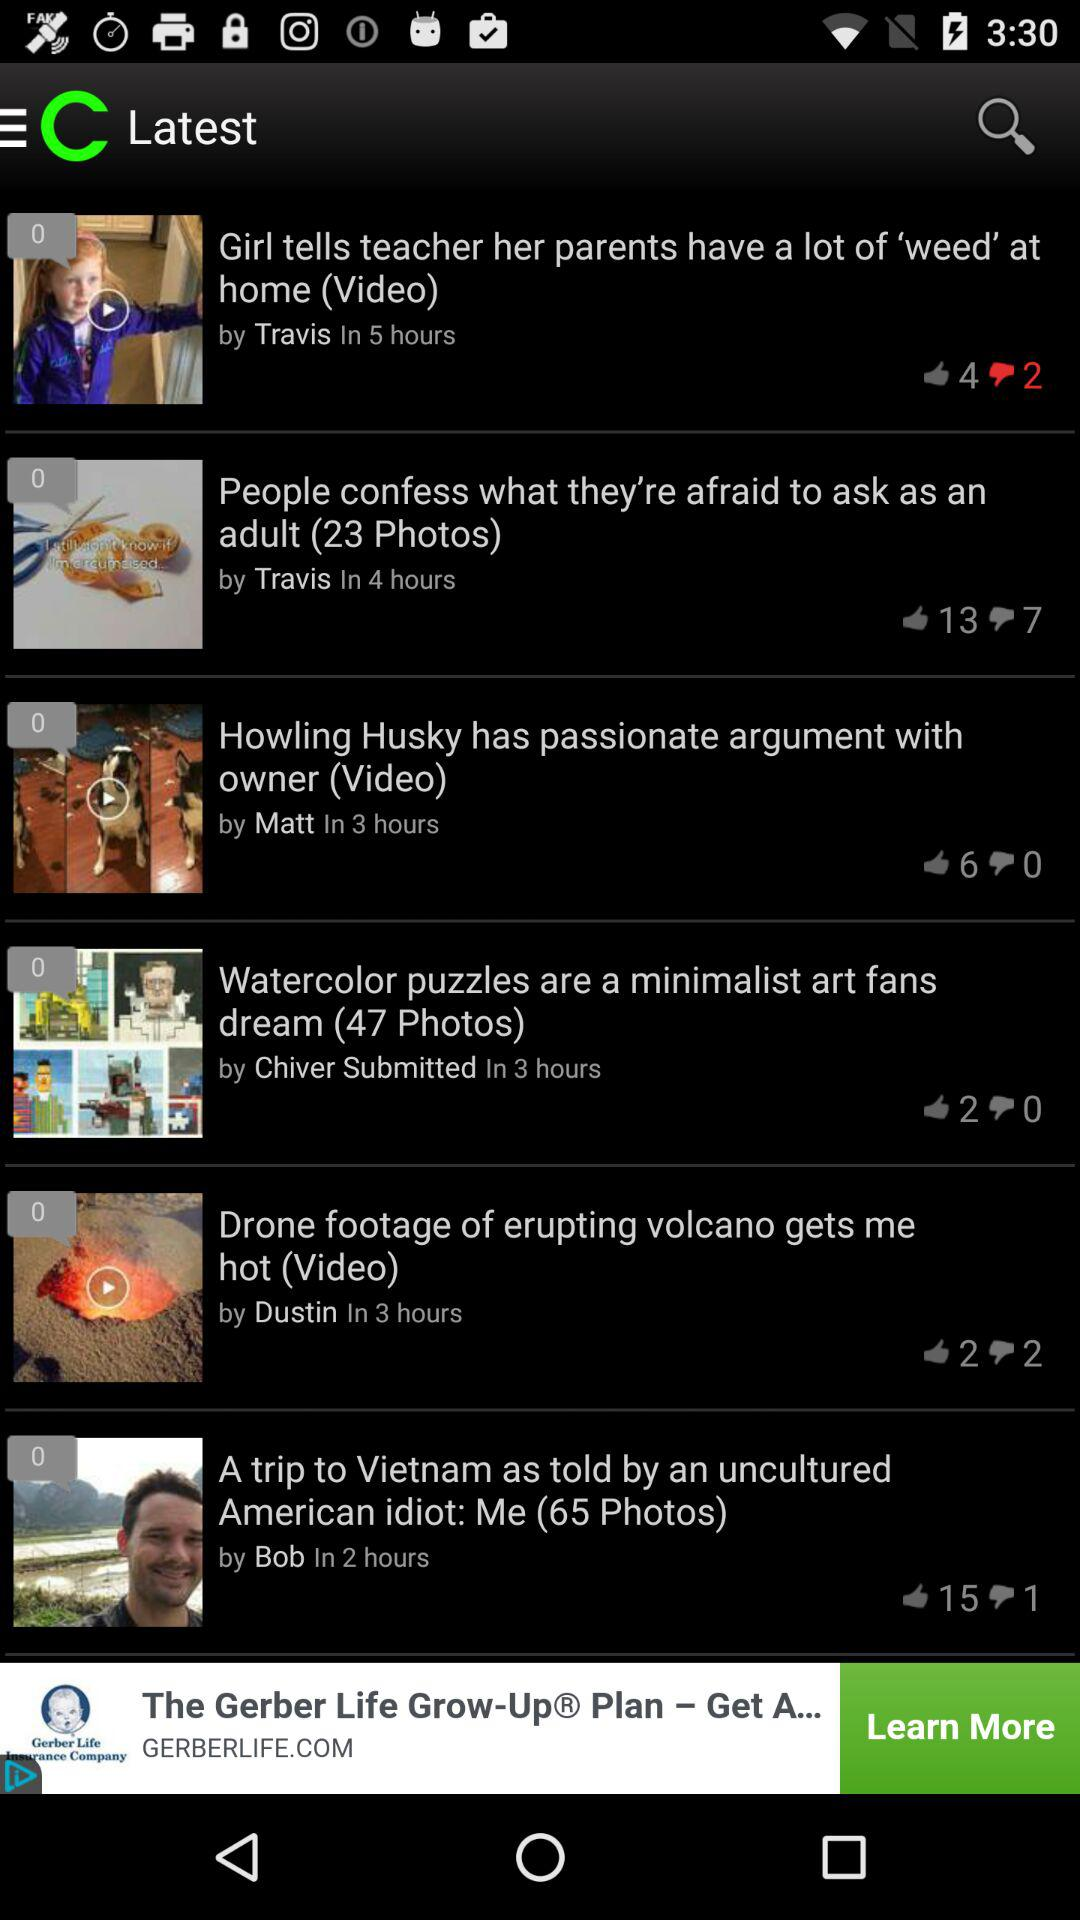When was "Drone footage of erupting volcano gets me hot" posted? "Drone footage of erupting volcano gets me hot" was posted 3 hours ago. 